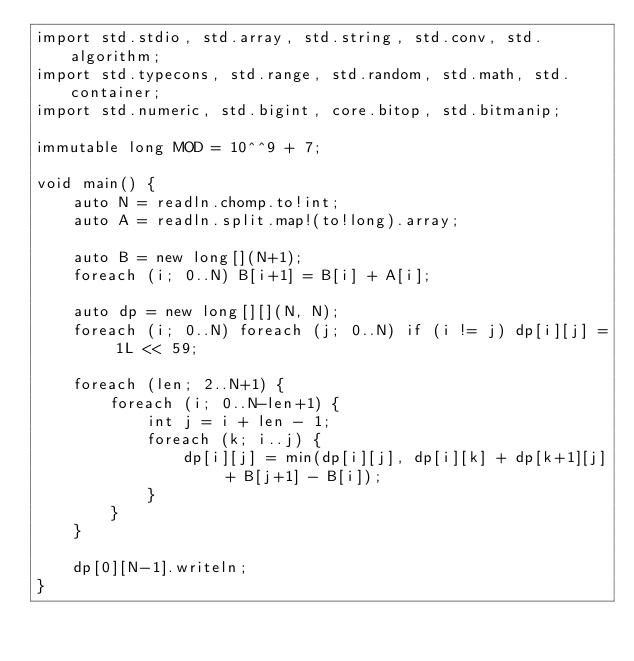Convert code to text. <code><loc_0><loc_0><loc_500><loc_500><_D_>import std.stdio, std.array, std.string, std.conv, std.algorithm;
import std.typecons, std.range, std.random, std.math, std.container;
import std.numeric, std.bigint, core.bitop, std.bitmanip;

immutable long MOD = 10^^9 + 7;

void main() {
    auto N = readln.chomp.to!int;
    auto A = readln.split.map!(to!long).array;

    auto B = new long[](N+1);
    foreach (i; 0..N) B[i+1] = B[i] + A[i];

    auto dp = new long[][](N, N);
    foreach (i; 0..N) foreach (j; 0..N) if (i != j) dp[i][j] = 1L << 59;

    foreach (len; 2..N+1) {
        foreach (i; 0..N-len+1) {
            int j = i + len - 1;
            foreach (k; i..j) {
                dp[i][j] = min(dp[i][j], dp[i][k] + dp[k+1][j] + B[j+1] - B[i]);
            }
        }
    }

    dp[0][N-1].writeln;
}
</code> 